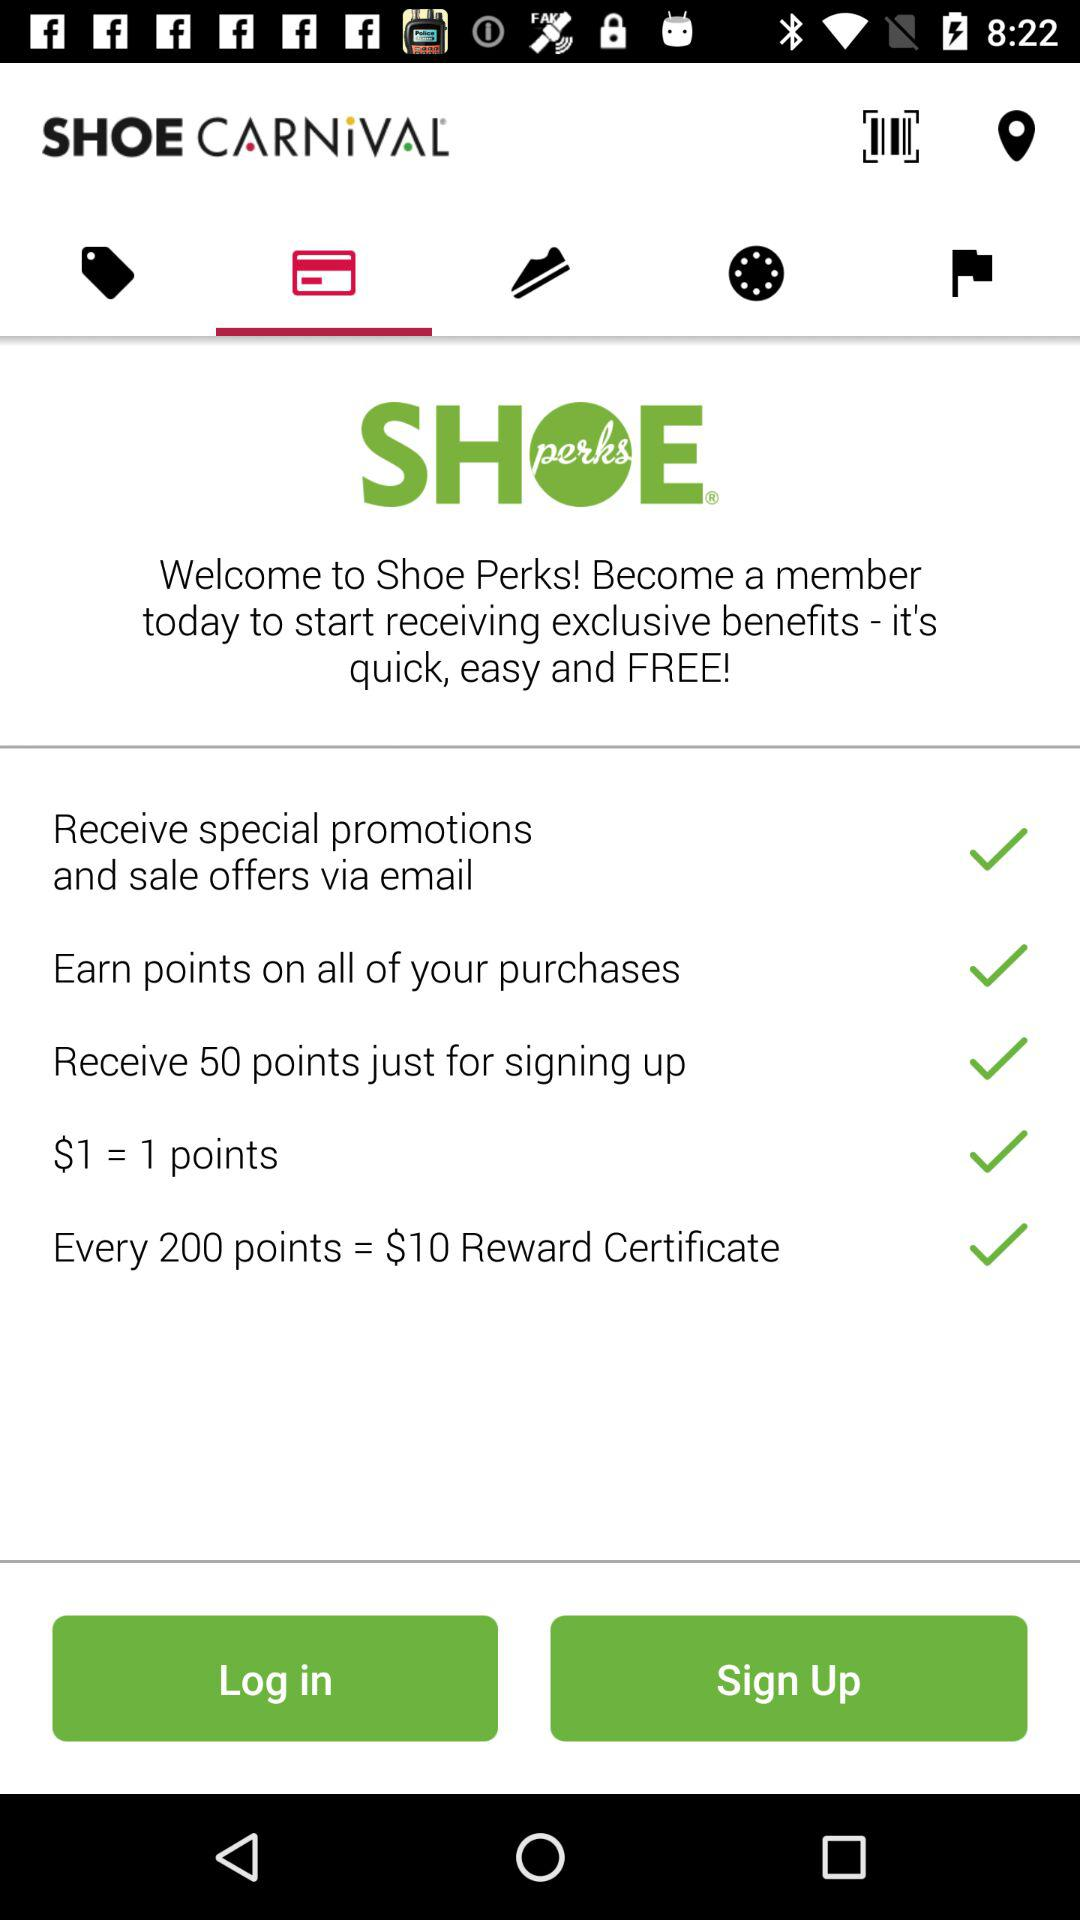How many points can I earn by signing up? You can earn 50 points by signing up. 